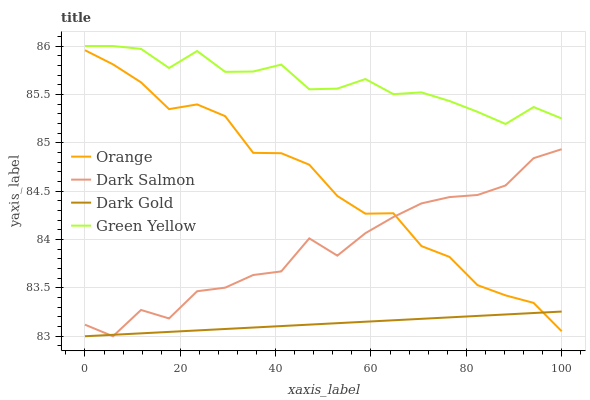Does Dark Gold have the minimum area under the curve?
Answer yes or no. Yes. Does Green Yellow have the maximum area under the curve?
Answer yes or no. Yes. Does Dark Salmon have the minimum area under the curve?
Answer yes or no. No. Does Dark Salmon have the maximum area under the curve?
Answer yes or no. No. Is Dark Gold the smoothest?
Answer yes or no. Yes. Is Dark Salmon the roughest?
Answer yes or no. Yes. Is Green Yellow the smoothest?
Answer yes or no. No. Is Green Yellow the roughest?
Answer yes or no. No. Does Green Yellow have the lowest value?
Answer yes or no. No. Does Green Yellow have the highest value?
Answer yes or no. Yes. Does Dark Salmon have the highest value?
Answer yes or no. No. Is Dark Salmon less than Green Yellow?
Answer yes or no. Yes. Is Green Yellow greater than Orange?
Answer yes or no. Yes. Does Dark Salmon intersect Green Yellow?
Answer yes or no. No. 